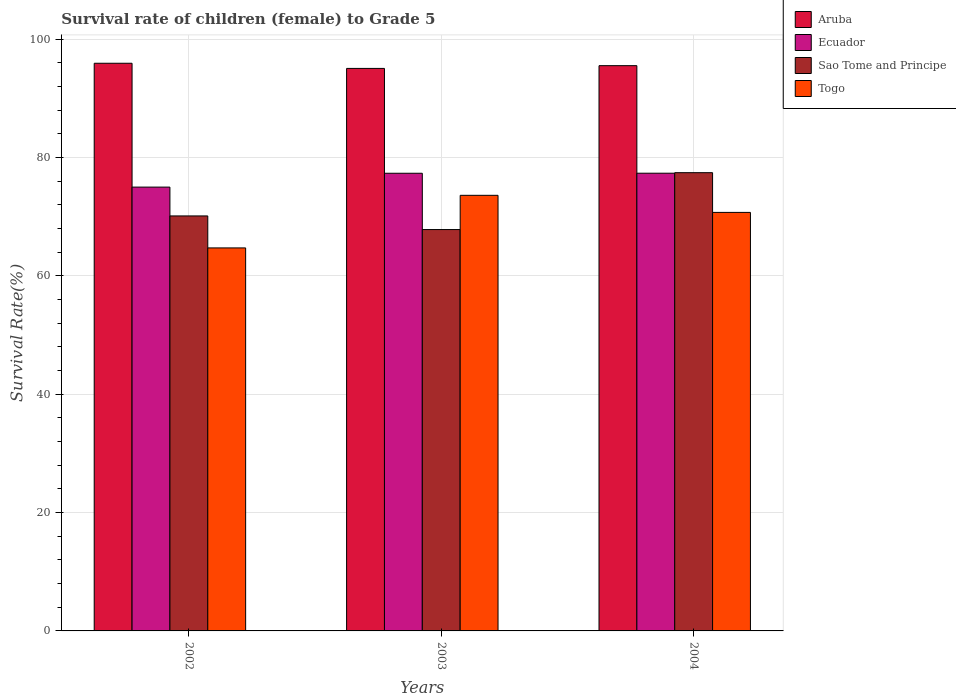How many different coloured bars are there?
Your answer should be compact. 4. Are the number of bars on each tick of the X-axis equal?
Ensure brevity in your answer.  Yes. How many bars are there on the 2nd tick from the left?
Provide a short and direct response. 4. How many bars are there on the 2nd tick from the right?
Ensure brevity in your answer.  4. What is the survival rate of female children to grade 5 in Ecuador in 2003?
Keep it short and to the point. 77.33. Across all years, what is the maximum survival rate of female children to grade 5 in Sao Tome and Principe?
Provide a short and direct response. 77.43. Across all years, what is the minimum survival rate of female children to grade 5 in Ecuador?
Your response must be concise. 74.99. What is the total survival rate of female children to grade 5 in Sao Tome and Principe in the graph?
Ensure brevity in your answer.  215.37. What is the difference between the survival rate of female children to grade 5 in Ecuador in 2002 and that in 2004?
Provide a short and direct response. -2.35. What is the difference between the survival rate of female children to grade 5 in Aruba in 2003 and the survival rate of female children to grade 5 in Togo in 2004?
Keep it short and to the point. 24.33. What is the average survival rate of female children to grade 5 in Togo per year?
Provide a succinct answer. 69.68. In the year 2004, what is the difference between the survival rate of female children to grade 5 in Togo and survival rate of female children to grade 5 in Ecuador?
Your answer should be very brief. -6.62. In how many years, is the survival rate of female children to grade 5 in Aruba greater than 84 %?
Ensure brevity in your answer.  3. What is the ratio of the survival rate of female children to grade 5 in Togo in 2002 to that in 2004?
Provide a succinct answer. 0.92. Is the difference between the survival rate of female children to grade 5 in Togo in 2002 and 2004 greater than the difference between the survival rate of female children to grade 5 in Ecuador in 2002 and 2004?
Your answer should be compact. No. What is the difference between the highest and the second highest survival rate of female children to grade 5 in Ecuador?
Provide a succinct answer. 0.01. What is the difference between the highest and the lowest survival rate of female children to grade 5 in Sao Tome and Principe?
Ensure brevity in your answer.  9.61. Is the sum of the survival rate of female children to grade 5 in Sao Tome and Principe in 2003 and 2004 greater than the maximum survival rate of female children to grade 5 in Aruba across all years?
Ensure brevity in your answer.  Yes. What does the 4th bar from the left in 2003 represents?
Provide a succinct answer. Togo. What does the 1st bar from the right in 2002 represents?
Provide a short and direct response. Togo. Are all the bars in the graph horizontal?
Offer a very short reply. No. How many years are there in the graph?
Keep it short and to the point. 3. Are the values on the major ticks of Y-axis written in scientific E-notation?
Keep it short and to the point. No. Does the graph contain grids?
Ensure brevity in your answer.  Yes. Where does the legend appear in the graph?
Provide a succinct answer. Top right. How many legend labels are there?
Your answer should be very brief. 4. What is the title of the graph?
Keep it short and to the point. Survival rate of children (female) to Grade 5. Does "High income: nonOECD" appear as one of the legend labels in the graph?
Keep it short and to the point. No. What is the label or title of the X-axis?
Provide a succinct answer. Years. What is the label or title of the Y-axis?
Your answer should be compact. Survival Rate(%). What is the Survival Rate(%) in Aruba in 2002?
Offer a very short reply. 95.92. What is the Survival Rate(%) in Ecuador in 2002?
Offer a terse response. 74.99. What is the Survival Rate(%) in Sao Tome and Principe in 2002?
Your answer should be very brief. 70.12. What is the Survival Rate(%) of Togo in 2002?
Your response must be concise. 64.72. What is the Survival Rate(%) in Aruba in 2003?
Offer a very short reply. 95.05. What is the Survival Rate(%) in Ecuador in 2003?
Offer a terse response. 77.33. What is the Survival Rate(%) of Sao Tome and Principe in 2003?
Make the answer very short. 67.82. What is the Survival Rate(%) in Togo in 2003?
Keep it short and to the point. 73.6. What is the Survival Rate(%) of Aruba in 2004?
Provide a short and direct response. 95.51. What is the Survival Rate(%) in Ecuador in 2004?
Make the answer very short. 77.34. What is the Survival Rate(%) of Sao Tome and Principe in 2004?
Offer a very short reply. 77.43. What is the Survival Rate(%) of Togo in 2004?
Your answer should be very brief. 70.72. Across all years, what is the maximum Survival Rate(%) in Aruba?
Your answer should be compact. 95.92. Across all years, what is the maximum Survival Rate(%) in Ecuador?
Ensure brevity in your answer.  77.34. Across all years, what is the maximum Survival Rate(%) of Sao Tome and Principe?
Offer a terse response. 77.43. Across all years, what is the maximum Survival Rate(%) of Togo?
Keep it short and to the point. 73.6. Across all years, what is the minimum Survival Rate(%) of Aruba?
Give a very brief answer. 95.05. Across all years, what is the minimum Survival Rate(%) of Ecuador?
Offer a very short reply. 74.99. Across all years, what is the minimum Survival Rate(%) of Sao Tome and Principe?
Provide a short and direct response. 67.82. Across all years, what is the minimum Survival Rate(%) in Togo?
Give a very brief answer. 64.72. What is the total Survival Rate(%) in Aruba in the graph?
Give a very brief answer. 286.47. What is the total Survival Rate(%) of Ecuador in the graph?
Ensure brevity in your answer.  229.66. What is the total Survival Rate(%) in Sao Tome and Principe in the graph?
Provide a succinct answer. 215.37. What is the total Survival Rate(%) in Togo in the graph?
Your answer should be compact. 209.03. What is the difference between the Survival Rate(%) in Aruba in 2002 and that in 2003?
Your answer should be very brief. 0.87. What is the difference between the Survival Rate(%) in Ecuador in 2002 and that in 2003?
Your answer should be compact. -2.34. What is the difference between the Survival Rate(%) of Sao Tome and Principe in 2002 and that in 2003?
Make the answer very short. 2.3. What is the difference between the Survival Rate(%) of Togo in 2002 and that in 2003?
Your answer should be compact. -8.89. What is the difference between the Survival Rate(%) in Aruba in 2002 and that in 2004?
Ensure brevity in your answer.  0.41. What is the difference between the Survival Rate(%) of Ecuador in 2002 and that in 2004?
Provide a short and direct response. -2.35. What is the difference between the Survival Rate(%) of Sao Tome and Principe in 2002 and that in 2004?
Give a very brief answer. -7.31. What is the difference between the Survival Rate(%) in Togo in 2002 and that in 2004?
Keep it short and to the point. -6. What is the difference between the Survival Rate(%) of Aruba in 2003 and that in 2004?
Offer a terse response. -0.46. What is the difference between the Survival Rate(%) of Ecuador in 2003 and that in 2004?
Make the answer very short. -0.01. What is the difference between the Survival Rate(%) of Sao Tome and Principe in 2003 and that in 2004?
Keep it short and to the point. -9.61. What is the difference between the Survival Rate(%) in Togo in 2003 and that in 2004?
Give a very brief answer. 2.88. What is the difference between the Survival Rate(%) of Aruba in 2002 and the Survival Rate(%) of Ecuador in 2003?
Offer a terse response. 18.59. What is the difference between the Survival Rate(%) of Aruba in 2002 and the Survival Rate(%) of Sao Tome and Principe in 2003?
Offer a very short reply. 28.1. What is the difference between the Survival Rate(%) in Aruba in 2002 and the Survival Rate(%) in Togo in 2003?
Your answer should be compact. 22.32. What is the difference between the Survival Rate(%) in Ecuador in 2002 and the Survival Rate(%) in Sao Tome and Principe in 2003?
Give a very brief answer. 7.17. What is the difference between the Survival Rate(%) of Ecuador in 2002 and the Survival Rate(%) of Togo in 2003?
Offer a very short reply. 1.39. What is the difference between the Survival Rate(%) in Sao Tome and Principe in 2002 and the Survival Rate(%) in Togo in 2003?
Provide a short and direct response. -3.48. What is the difference between the Survival Rate(%) in Aruba in 2002 and the Survival Rate(%) in Ecuador in 2004?
Ensure brevity in your answer.  18.58. What is the difference between the Survival Rate(%) in Aruba in 2002 and the Survival Rate(%) in Sao Tome and Principe in 2004?
Your answer should be very brief. 18.49. What is the difference between the Survival Rate(%) of Aruba in 2002 and the Survival Rate(%) of Togo in 2004?
Keep it short and to the point. 25.2. What is the difference between the Survival Rate(%) in Ecuador in 2002 and the Survival Rate(%) in Sao Tome and Principe in 2004?
Provide a short and direct response. -2.44. What is the difference between the Survival Rate(%) of Ecuador in 2002 and the Survival Rate(%) of Togo in 2004?
Offer a very short reply. 4.27. What is the difference between the Survival Rate(%) in Sao Tome and Principe in 2002 and the Survival Rate(%) in Togo in 2004?
Provide a succinct answer. -0.6. What is the difference between the Survival Rate(%) in Aruba in 2003 and the Survival Rate(%) in Ecuador in 2004?
Make the answer very short. 17.71. What is the difference between the Survival Rate(%) in Aruba in 2003 and the Survival Rate(%) in Sao Tome and Principe in 2004?
Your answer should be very brief. 17.62. What is the difference between the Survival Rate(%) of Aruba in 2003 and the Survival Rate(%) of Togo in 2004?
Offer a terse response. 24.33. What is the difference between the Survival Rate(%) of Ecuador in 2003 and the Survival Rate(%) of Sao Tome and Principe in 2004?
Your answer should be compact. -0.1. What is the difference between the Survival Rate(%) in Ecuador in 2003 and the Survival Rate(%) in Togo in 2004?
Ensure brevity in your answer.  6.61. What is the average Survival Rate(%) in Aruba per year?
Provide a succinct answer. 95.49. What is the average Survival Rate(%) of Ecuador per year?
Make the answer very short. 76.55. What is the average Survival Rate(%) of Sao Tome and Principe per year?
Ensure brevity in your answer.  71.79. What is the average Survival Rate(%) of Togo per year?
Your answer should be compact. 69.68. In the year 2002, what is the difference between the Survival Rate(%) of Aruba and Survival Rate(%) of Ecuador?
Your answer should be compact. 20.93. In the year 2002, what is the difference between the Survival Rate(%) of Aruba and Survival Rate(%) of Sao Tome and Principe?
Your answer should be very brief. 25.8. In the year 2002, what is the difference between the Survival Rate(%) in Aruba and Survival Rate(%) in Togo?
Provide a succinct answer. 31.2. In the year 2002, what is the difference between the Survival Rate(%) of Ecuador and Survival Rate(%) of Sao Tome and Principe?
Make the answer very short. 4.87. In the year 2002, what is the difference between the Survival Rate(%) of Ecuador and Survival Rate(%) of Togo?
Your answer should be compact. 10.28. In the year 2002, what is the difference between the Survival Rate(%) in Sao Tome and Principe and Survival Rate(%) in Togo?
Give a very brief answer. 5.4. In the year 2003, what is the difference between the Survival Rate(%) in Aruba and Survival Rate(%) in Ecuador?
Give a very brief answer. 17.72. In the year 2003, what is the difference between the Survival Rate(%) in Aruba and Survival Rate(%) in Sao Tome and Principe?
Offer a terse response. 27.23. In the year 2003, what is the difference between the Survival Rate(%) in Aruba and Survival Rate(%) in Togo?
Your answer should be very brief. 21.44. In the year 2003, what is the difference between the Survival Rate(%) of Ecuador and Survival Rate(%) of Sao Tome and Principe?
Provide a succinct answer. 9.51. In the year 2003, what is the difference between the Survival Rate(%) of Ecuador and Survival Rate(%) of Togo?
Your response must be concise. 3.73. In the year 2003, what is the difference between the Survival Rate(%) of Sao Tome and Principe and Survival Rate(%) of Togo?
Ensure brevity in your answer.  -5.78. In the year 2004, what is the difference between the Survival Rate(%) of Aruba and Survival Rate(%) of Ecuador?
Provide a succinct answer. 18.17. In the year 2004, what is the difference between the Survival Rate(%) of Aruba and Survival Rate(%) of Sao Tome and Principe?
Make the answer very short. 18.08. In the year 2004, what is the difference between the Survival Rate(%) in Aruba and Survival Rate(%) in Togo?
Keep it short and to the point. 24.79. In the year 2004, what is the difference between the Survival Rate(%) in Ecuador and Survival Rate(%) in Sao Tome and Principe?
Keep it short and to the point. -0.09. In the year 2004, what is the difference between the Survival Rate(%) of Ecuador and Survival Rate(%) of Togo?
Your answer should be compact. 6.62. In the year 2004, what is the difference between the Survival Rate(%) in Sao Tome and Principe and Survival Rate(%) in Togo?
Provide a short and direct response. 6.71. What is the ratio of the Survival Rate(%) of Aruba in 2002 to that in 2003?
Offer a very short reply. 1.01. What is the ratio of the Survival Rate(%) in Ecuador in 2002 to that in 2003?
Ensure brevity in your answer.  0.97. What is the ratio of the Survival Rate(%) in Sao Tome and Principe in 2002 to that in 2003?
Your response must be concise. 1.03. What is the ratio of the Survival Rate(%) of Togo in 2002 to that in 2003?
Keep it short and to the point. 0.88. What is the ratio of the Survival Rate(%) in Aruba in 2002 to that in 2004?
Provide a short and direct response. 1. What is the ratio of the Survival Rate(%) of Ecuador in 2002 to that in 2004?
Keep it short and to the point. 0.97. What is the ratio of the Survival Rate(%) in Sao Tome and Principe in 2002 to that in 2004?
Your response must be concise. 0.91. What is the ratio of the Survival Rate(%) in Togo in 2002 to that in 2004?
Make the answer very short. 0.92. What is the ratio of the Survival Rate(%) in Sao Tome and Principe in 2003 to that in 2004?
Provide a succinct answer. 0.88. What is the ratio of the Survival Rate(%) in Togo in 2003 to that in 2004?
Ensure brevity in your answer.  1.04. What is the difference between the highest and the second highest Survival Rate(%) of Aruba?
Your answer should be very brief. 0.41. What is the difference between the highest and the second highest Survival Rate(%) in Ecuador?
Provide a succinct answer. 0.01. What is the difference between the highest and the second highest Survival Rate(%) of Sao Tome and Principe?
Provide a succinct answer. 7.31. What is the difference between the highest and the second highest Survival Rate(%) of Togo?
Give a very brief answer. 2.88. What is the difference between the highest and the lowest Survival Rate(%) in Aruba?
Keep it short and to the point. 0.87. What is the difference between the highest and the lowest Survival Rate(%) in Ecuador?
Keep it short and to the point. 2.35. What is the difference between the highest and the lowest Survival Rate(%) of Sao Tome and Principe?
Ensure brevity in your answer.  9.61. What is the difference between the highest and the lowest Survival Rate(%) of Togo?
Your response must be concise. 8.89. 